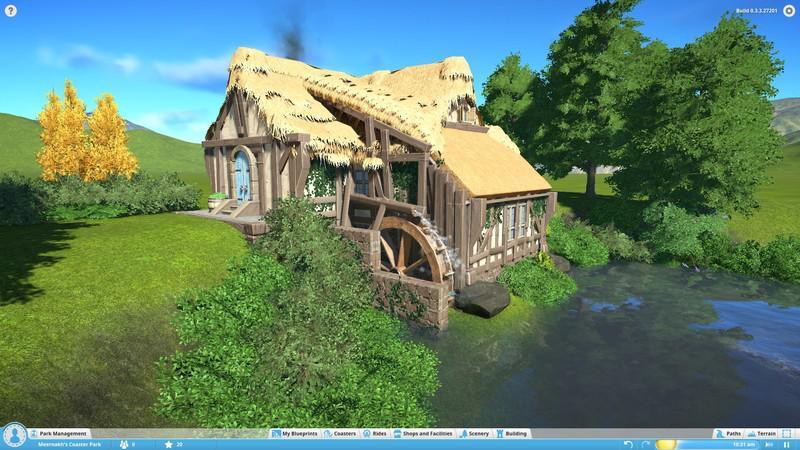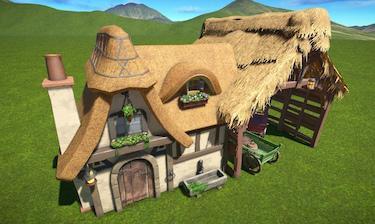The first image is the image on the left, the second image is the image on the right. Evaluate the accuracy of this statement regarding the images: "The right image features a building with a roof featuring an inverted cone-shape with gray Xs on it, over arch windows that are above an arch door.". Is it true? Answer yes or no. Yes. The first image is the image on the left, the second image is the image on the right. Assess this claim about the two images: "The left and right image contains a total of two home.". Correct or not? Answer yes or no. Yes. 